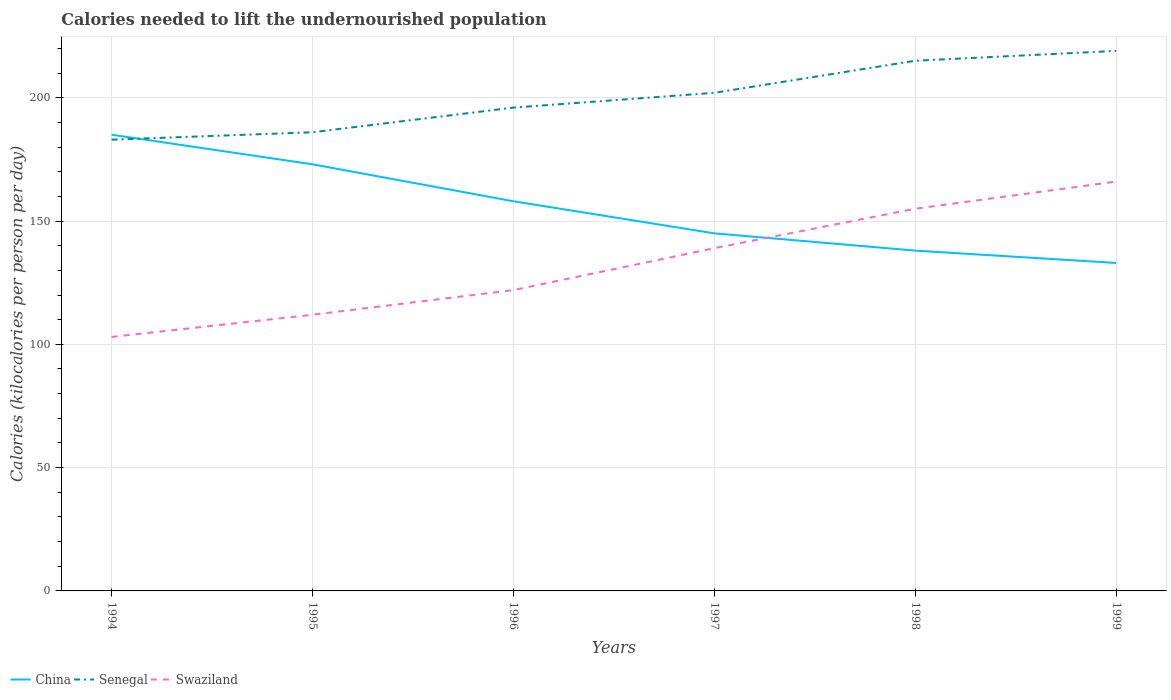Does the line corresponding to China intersect with the line corresponding to Senegal?
Your answer should be compact. Yes. Across all years, what is the maximum total calories needed to lift the undernourished population in China?
Your response must be concise. 133. In which year was the total calories needed to lift the undernourished population in Senegal maximum?
Make the answer very short. 1994. What is the total total calories needed to lift the undernourished population in China in the graph?
Offer a very short reply. 35. What is the difference between the highest and the second highest total calories needed to lift the undernourished population in Senegal?
Provide a short and direct response. 36. What is the difference between the highest and the lowest total calories needed to lift the undernourished population in Senegal?
Ensure brevity in your answer.  3. Is the total calories needed to lift the undernourished population in China strictly greater than the total calories needed to lift the undernourished population in Senegal over the years?
Ensure brevity in your answer.  No. How many lines are there?
Ensure brevity in your answer.  3. How many years are there in the graph?
Ensure brevity in your answer.  6. Are the values on the major ticks of Y-axis written in scientific E-notation?
Your response must be concise. No. Where does the legend appear in the graph?
Make the answer very short. Bottom left. How many legend labels are there?
Your answer should be very brief. 3. What is the title of the graph?
Your answer should be compact. Calories needed to lift the undernourished population. What is the label or title of the Y-axis?
Provide a short and direct response. Calories (kilocalories per person per day). What is the Calories (kilocalories per person per day) of China in 1994?
Ensure brevity in your answer.  185. What is the Calories (kilocalories per person per day) in Senegal in 1994?
Give a very brief answer. 183. What is the Calories (kilocalories per person per day) of Swaziland in 1994?
Offer a very short reply. 103. What is the Calories (kilocalories per person per day) of China in 1995?
Your response must be concise. 173. What is the Calories (kilocalories per person per day) of Senegal in 1995?
Ensure brevity in your answer.  186. What is the Calories (kilocalories per person per day) in Swaziland in 1995?
Provide a succinct answer. 112. What is the Calories (kilocalories per person per day) in China in 1996?
Provide a succinct answer. 158. What is the Calories (kilocalories per person per day) of Senegal in 1996?
Provide a succinct answer. 196. What is the Calories (kilocalories per person per day) in Swaziland in 1996?
Keep it short and to the point. 122. What is the Calories (kilocalories per person per day) of China in 1997?
Provide a succinct answer. 145. What is the Calories (kilocalories per person per day) of Senegal in 1997?
Your answer should be compact. 202. What is the Calories (kilocalories per person per day) of Swaziland in 1997?
Keep it short and to the point. 139. What is the Calories (kilocalories per person per day) of China in 1998?
Provide a short and direct response. 138. What is the Calories (kilocalories per person per day) in Senegal in 1998?
Ensure brevity in your answer.  215. What is the Calories (kilocalories per person per day) in Swaziland in 1998?
Make the answer very short. 155. What is the Calories (kilocalories per person per day) in China in 1999?
Your answer should be very brief. 133. What is the Calories (kilocalories per person per day) of Senegal in 1999?
Ensure brevity in your answer.  219. What is the Calories (kilocalories per person per day) of Swaziland in 1999?
Provide a succinct answer. 166. Across all years, what is the maximum Calories (kilocalories per person per day) in China?
Offer a terse response. 185. Across all years, what is the maximum Calories (kilocalories per person per day) in Senegal?
Give a very brief answer. 219. Across all years, what is the maximum Calories (kilocalories per person per day) in Swaziland?
Provide a succinct answer. 166. Across all years, what is the minimum Calories (kilocalories per person per day) in China?
Your answer should be compact. 133. Across all years, what is the minimum Calories (kilocalories per person per day) of Senegal?
Give a very brief answer. 183. Across all years, what is the minimum Calories (kilocalories per person per day) in Swaziland?
Your answer should be compact. 103. What is the total Calories (kilocalories per person per day) of China in the graph?
Keep it short and to the point. 932. What is the total Calories (kilocalories per person per day) of Senegal in the graph?
Provide a succinct answer. 1201. What is the total Calories (kilocalories per person per day) of Swaziland in the graph?
Your answer should be compact. 797. What is the difference between the Calories (kilocalories per person per day) in China in 1994 and that in 1995?
Offer a very short reply. 12. What is the difference between the Calories (kilocalories per person per day) in Senegal in 1994 and that in 1995?
Offer a very short reply. -3. What is the difference between the Calories (kilocalories per person per day) in China in 1994 and that in 1996?
Provide a short and direct response. 27. What is the difference between the Calories (kilocalories per person per day) in Senegal in 1994 and that in 1996?
Ensure brevity in your answer.  -13. What is the difference between the Calories (kilocalories per person per day) of Swaziland in 1994 and that in 1996?
Your answer should be very brief. -19. What is the difference between the Calories (kilocalories per person per day) in China in 1994 and that in 1997?
Make the answer very short. 40. What is the difference between the Calories (kilocalories per person per day) of Senegal in 1994 and that in 1997?
Provide a succinct answer. -19. What is the difference between the Calories (kilocalories per person per day) in Swaziland in 1994 and that in 1997?
Keep it short and to the point. -36. What is the difference between the Calories (kilocalories per person per day) of Senegal in 1994 and that in 1998?
Keep it short and to the point. -32. What is the difference between the Calories (kilocalories per person per day) of Swaziland in 1994 and that in 1998?
Provide a succinct answer. -52. What is the difference between the Calories (kilocalories per person per day) in Senegal in 1994 and that in 1999?
Give a very brief answer. -36. What is the difference between the Calories (kilocalories per person per day) of Swaziland in 1994 and that in 1999?
Offer a very short reply. -63. What is the difference between the Calories (kilocalories per person per day) in Swaziland in 1995 and that in 1996?
Provide a succinct answer. -10. What is the difference between the Calories (kilocalories per person per day) of Swaziland in 1995 and that in 1997?
Your answer should be compact. -27. What is the difference between the Calories (kilocalories per person per day) in China in 1995 and that in 1998?
Offer a very short reply. 35. What is the difference between the Calories (kilocalories per person per day) of Swaziland in 1995 and that in 1998?
Provide a short and direct response. -43. What is the difference between the Calories (kilocalories per person per day) in China in 1995 and that in 1999?
Your answer should be compact. 40. What is the difference between the Calories (kilocalories per person per day) in Senegal in 1995 and that in 1999?
Your response must be concise. -33. What is the difference between the Calories (kilocalories per person per day) in Swaziland in 1995 and that in 1999?
Give a very brief answer. -54. What is the difference between the Calories (kilocalories per person per day) of China in 1996 and that in 1997?
Offer a very short reply. 13. What is the difference between the Calories (kilocalories per person per day) in Senegal in 1996 and that in 1998?
Ensure brevity in your answer.  -19. What is the difference between the Calories (kilocalories per person per day) of Swaziland in 1996 and that in 1998?
Keep it short and to the point. -33. What is the difference between the Calories (kilocalories per person per day) of Swaziland in 1996 and that in 1999?
Offer a very short reply. -44. What is the difference between the Calories (kilocalories per person per day) in Senegal in 1997 and that in 1998?
Offer a very short reply. -13. What is the difference between the Calories (kilocalories per person per day) of Swaziland in 1997 and that in 1998?
Offer a terse response. -16. What is the difference between the Calories (kilocalories per person per day) of China in 1997 and that in 1999?
Keep it short and to the point. 12. What is the difference between the Calories (kilocalories per person per day) in Swaziland in 1997 and that in 1999?
Your answer should be very brief. -27. What is the difference between the Calories (kilocalories per person per day) of China in 1998 and that in 1999?
Your answer should be compact. 5. What is the difference between the Calories (kilocalories per person per day) of Senegal in 1998 and that in 1999?
Your response must be concise. -4. What is the difference between the Calories (kilocalories per person per day) of China in 1994 and the Calories (kilocalories per person per day) of Swaziland in 1995?
Make the answer very short. 73. What is the difference between the Calories (kilocalories per person per day) in Senegal in 1994 and the Calories (kilocalories per person per day) in Swaziland in 1996?
Keep it short and to the point. 61. What is the difference between the Calories (kilocalories per person per day) in China in 1994 and the Calories (kilocalories per person per day) in Swaziland in 1997?
Your response must be concise. 46. What is the difference between the Calories (kilocalories per person per day) of China in 1994 and the Calories (kilocalories per person per day) of Senegal in 1998?
Provide a succinct answer. -30. What is the difference between the Calories (kilocalories per person per day) of China in 1994 and the Calories (kilocalories per person per day) of Senegal in 1999?
Provide a succinct answer. -34. What is the difference between the Calories (kilocalories per person per day) of China in 1994 and the Calories (kilocalories per person per day) of Swaziland in 1999?
Provide a short and direct response. 19. What is the difference between the Calories (kilocalories per person per day) in Senegal in 1994 and the Calories (kilocalories per person per day) in Swaziland in 1999?
Ensure brevity in your answer.  17. What is the difference between the Calories (kilocalories per person per day) in China in 1995 and the Calories (kilocalories per person per day) in Senegal in 1997?
Provide a short and direct response. -29. What is the difference between the Calories (kilocalories per person per day) in China in 1995 and the Calories (kilocalories per person per day) in Swaziland in 1997?
Give a very brief answer. 34. What is the difference between the Calories (kilocalories per person per day) in Senegal in 1995 and the Calories (kilocalories per person per day) in Swaziland in 1997?
Make the answer very short. 47. What is the difference between the Calories (kilocalories per person per day) of China in 1995 and the Calories (kilocalories per person per day) of Senegal in 1998?
Make the answer very short. -42. What is the difference between the Calories (kilocalories per person per day) in China in 1995 and the Calories (kilocalories per person per day) in Senegal in 1999?
Your answer should be very brief. -46. What is the difference between the Calories (kilocalories per person per day) of China in 1996 and the Calories (kilocalories per person per day) of Senegal in 1997?
Offer a very short reply. -44. What is the difference between the Calories (kilocalories per person per day) in China in 1996 and the Calories (kilocalories per person per day) in Swaziland in 1997?
Give a very brief answer. 19. What is the difference between the Calories (kilocalories per person per day) of China in 1996 and the Calories (kilocalories per person per day) of Senegal in 1998?
Your answer should be very brief. -57. What is the difference between the Calories (kilocalories per person per day) of Senegal in 1996 and the Calories (kilocalories per person per day) of Swaziland in 1998?
Offer a terse response. 41. What is the difference between the Calories (kilocalories per person per day) in China in 1996 and the Calories (kilocalories per person per day) in Senegal in 1999?
Provide a short and direct response. -61. What is the difference between the Calories (kilocalories per person per day) in China in 1996 and the Calories (kilocalories per person per day) in Swaziland in 1999?
Ensure brevity in your answer.  -8. What is the difference between the Calories (kilocalories per person per day) of Senegal in 1996 and the Calories (kilocalories per person per day) of Swaziland in 1999?
Offer a very short reply. 30. What is the difference between the Calories (kilocalories per person per day) of China in 1997 and the Calories (kilocalories per person per day) of Senegal in 1998?
Offer a very short reply. -70. What is the difference between the Calories (kilocalories per person per day) of Senegal in 1997 and the Calories (kilocalories per person per day) of Swaziland in 1998?
Ensure brevity in your answer.  47. What is the difference between the Calories (kilocalories per person per day) of China in 1997 and the Calories (kilocalories per person per day) of Senegal in 1999?
Provide a short and direct response. -74. What is the difference between the Calories (kilocalories per person per day) of Senegal in 1997 and the Calories (kilocalories per person per day) of Swaziland in 1999?
Your answer should be compact. 36. What is the difference between the Calories (kilocalories per person per day) of China in 1998 and the Calories (kilocalories per person per day) of Senegal in 1999?
Provide a short and direct response. -81. What is the difference between the Calories (kilocalories per person per day) of Senegal in 1998 and the Calories (kilocalories per person per day) of Swaziland in 1999?
Offer a very short reply. 49. What is the average Calories (kilocalories per person per day) of China per year?
Provide a short and direct response. 155.33. What is the average Calories (kilocalories per person per day) in Senegal per year?
Make the answer very short. 200.17. What is the average Calories (kilocalories per person per day) in Swaziland per year?
Make the answer very short. 132.83. In the year 1994, what is the difference between the Calories (kilocalories per person per day) in China and Calories (kilocalories per person per day) in Swaziland?
Ensure brevity in your answer.  82. In the year 1994, what is the difference between the Calories (kilocalories per person per day) in Senegal and Calories (kilocalories per person per day) in Swaziland?
Offer a terse response. 80. In the year 1996, what is the difference between the Calories (kilocalories per person per day) in China and Calories (kilocalories per person per day) in Senegal?
Provide a short and direct response. -38. In the year 1996, what is the difference between the Calories (kilocalories per person per day) of Senegal and Calories (kilocalories per person per day) of Swaziland?
Offer a terse response. 74. In the year 1997, what is the difference between the Calories (kilocalories per person per day) in China and Calories (kilocalories per person per day) in Senegal?
Offer a terse response. -57. In the year 1997, what is the difference between the Calories (kilocalories per person per day) in China and Calories (kilocalories per person per day) in Swaziland?
Offer a terse response. 6. In the year 1998, what is the difference between the Calories (kilocalories per person per day) of China and Calories (kilocalories per person per day) of Senegal?
Your answer should be compact. -77. In the year 1998, what is the difference between the Calories (kilocalories per person per day) in China and Calories (kilocalories per person per day) in Swaziland?
Provide a short and direct response. -17. In the year 1999, what is the difference between the Calories (kilocalories per person per day) of China and Calories (kilocalories per person per day) of Senegal?
Your response must be concise. -86. In the year 1999, what is the difference between the Calories (kilocalories per person per day) of China and Calories (kilocalories per person per day) of Swaziland?
Provide a succinct answer. -33. What is the ratio of the Calories (kilocalories per person per day) of China in 1994 to that in 1995?
Give a very brief answer. 1.07. What is the ratio of the Calories (kilocalories per person per day) of Senegal in 1994 to that in 1995?
Your answer should be compact. 0.98. What is the ratio of the Calories (kilocalories per person per day) in Swaziland in 1994 to that in 1995?
Ensure brevity in your answer.  0.92. What is the ratio of the Calories (kilocalories per person per day) in China in 1994 to that in 1996?
Keep it short and to the point. 1.17. What is the ratio of the Calories (kilocalories per person per day) in Senegal in 1994 to that in 1996?
Offer a terse response. 0.93. What is the ratio of the Calories (kilocalories per person per day) of Swaziland in 1994 to that in 1996?
Give a very brief answer. 0.84. What is the ratio of the Calories (kilocalories per person per day) in China in 1994 to that in 1997?
Your answer should be compact. 1.28. What is the ratio of the Calories (kilocalories per person per day) in Senegal in 1994 to that in 1997?
Offer a very short reply. 0.91. What is the ratio of the Calories (kilocalories per person per day) of Swaziland in 1994 to that in 1997?
Ensure brevity in your answer.  0.74. What is the ratio of the Calories (kilocalories per person per day) in China in 1994 to that in 1998?
Offer a very short reply. 1.34. What is the ratio of the Calories (kilocalories per person per day) in Senegal in 1994 to that in 1998?
Give a very brief answer. 0.85. What is the ratio of the Calories (kilocalories per person per day) of Swaziland in 1994 to that in 1998?
Give a very brief answer. 0.66. What is the ratio of the Calories (kilocalories per person per day) of China in 1994 to that in 1999?
Make the answer very short. 1.39. What is the ratio of the Calories (kilocalories per person per day) of Senegal in 1994 to that in 1999?
Your answer should be compact. 0.84. What is the ratio of the Calories (kilocalories per person per day) of Swaziland in 1994 to that in 1999?
Provide a short and direct response. 0.62. What is the ratio of the Calories (kilocalories per person per day) in China in 1995 to that in 1996?
Make the answer very short. 1.09. What is the ratio of the Calories (kilocalories per person per day) of Senegal in 1995 to that in 1996?
Ensure brevity in your answer.  0.95. What is the ratio of the Calories (kilocalories per person per day) in Swaziland in 1995 to that in 1996?
Provide a succinct answer. 0.92. What is the ratio of the Calories (kilocalories per person per day) of China in 1995 to that in 1997?
Provide a short and direct response. 1.19. What is the ratio of the Calories (kilocalories per person per day) of Senegal in 1995 to that in 1997?
Your answer should be very brief. 0.92. What is the ratio of the Calories (kilocalories per person per day) of Swaziland in 1995 to that in 1997?
Provide a short and direct response. 0.81. What is the ratio of the Calories (kilocalories per person per day) in China in 1995 to that in 1998?
Give a very brief answer. 1.25. What is the ratio of the Calories (kilocalories per person per day) of Senegal in 1995 to that in 1998?
Ensure brevity in your answer.  0.87. What is the ratio of the Calories (kilocalories per person per day) in Swaziland in 1995 to that in 1998?
Offer a very short reply. 0.72. What is the ratio of the Calories (kilocalories per person per day) of China in 1995 to that in 1999?
Keep it short and to the point. 1.3. What is the ratio of the Calories (kilocalories per person per day) in Senegal in 1995 to that in 1999?
Your response must be concise. 0.85. What is the ratio of the Calories (kilocalories per person per day) in Swaziland in 1995 to that in 1999?
Your response must be concise. 0.67. What is the ratio of the Calories (kilocalories per person per day) of China in 1996 to that in 1997?
Provide a succinct answer. 1.09. What is the ratio of the Calories (kilocalories per person per day) in Senegal in 1996 to that in 1997?
Keep it short and to the point. 0.97. What is the ratio of the Calories (kilocalories per person per day) of Swaziland in 1996 to that in 1997?
Offer a very short reply. 0.88. What is the ratio of the Calories (kilocalories per person per day) in China in 1996 to that in 1998?
Provide a succinct answer. 1.14. What is the ratio of the Calories (kilocalories per person per day) in Senegal in 1996 to that in 1998?
Offer a very short reply. 0.91. What is the ratio of the Calories (kilocalories per person per day) in Swaziland in 1996 to that in 1998?
Your response must be concise. 0.79. What is the ratio of the Calories (kilocalories per person per day) of China in 1996 to that in 1999?
Offer a very short reply. 1.19. What is the ratio of the Calories (kilocalories per person per day) in Senegal in 1996 to that in 1999?
Your answer should be compact. 0.9. What is the ratio of the Calories (kilocalories per person per day) of Swaziland in 1996 to that in 1999?
Your answer should be very brief. 0.73. What is the ratio of the Calories (kilocalories per person per day) of China in 1997 to that in 1998?
Provide a short and direct response. 1.05. What is the ratio of the Calories (kilocalories per person per day) of Senegal in 1997 to that in 1998?
Give a very brief answer. 0.94. What is the ratio of the Calories (kilocalories per person per day) of Swaziland in 1997 to that in 1998?
Make the answer very short. 0.9. What is the ratio of the Calories (kilocalories per person per day) of China in 1997 to that in 1999?
Offer a terse response. 1.09. What is the ratio of the Calories (kilocalories per person per day) in Senegal in 1997 to that in 1999?
Provide a succinct answer. 0.92. What is the ratio of the Calories (kilocalories per person per day) in Swaziland in 1997 to that in 1999?
Offer a very short reply. 0.84. What is the ratio of the Calories (kilocalories per person per day) of China in 1998 to that in 1999?
Provide a short and direct response. 1.04. What is the ratio of the Calories (kilocalories per person per day) of Senegal in 1998 to that in 1999?
Your response must be concise. 0.98. What is the ratio of the Calories (kilocalories per person per day) in Swaziland in 1998 to that in 1999?
Your answer should be compact. 0.93. What is the difference between the highest and the second highest Calories (kilocalories per person per day) in Swaziland?
Your response must be concise. 11. What is the difference between the highest and the lowest Calories (kilocalories per person per day) in China?
Keep it short and to the point. 52. 